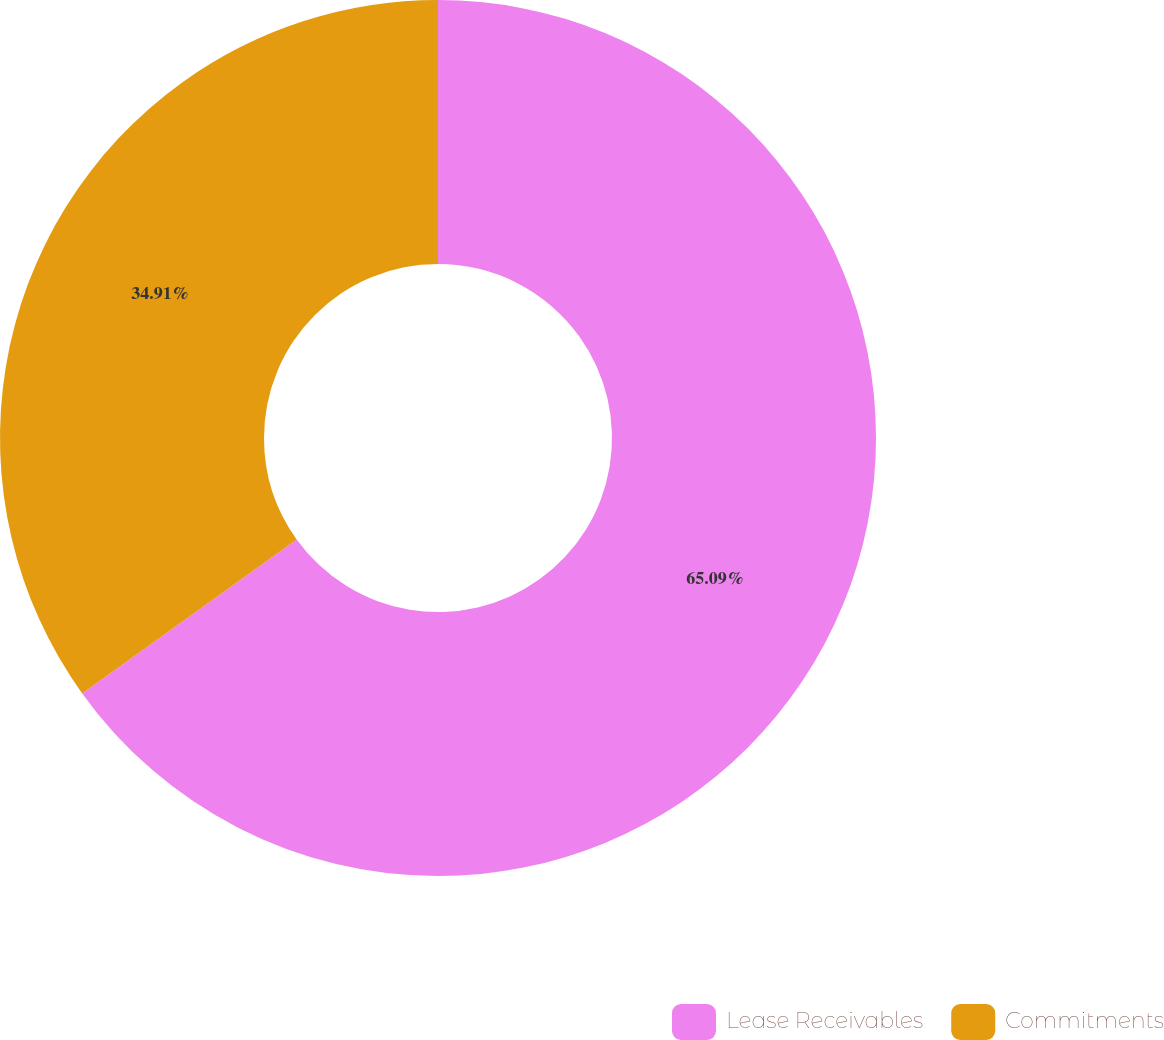Convert chart to OTSL. <chart><loc_0><loc_0><loc_500><loc_500><pie_chart><fcel>Lease Receivables<fcel>Commitments<nl><fcel>65.09%<fcel>34.91%<nl></chart> 